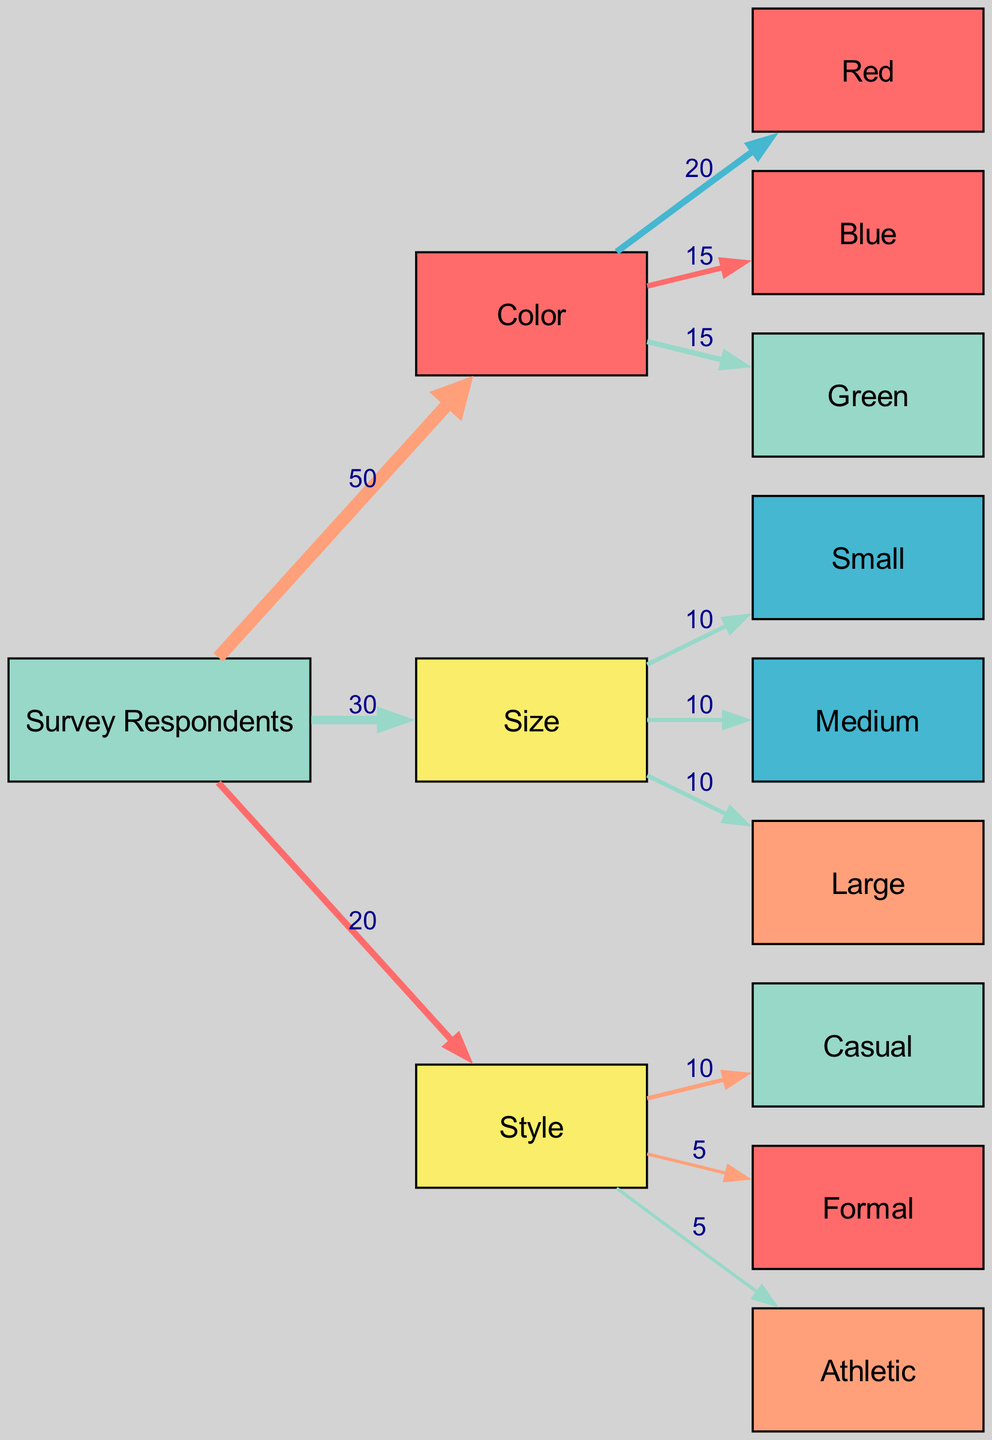What's the total number of survey respondents? The sum of all connections originating from the "Survey Respondents" node indicates the number of respondents. There is one link from "Survey Respondents" to each feature category (Color, Size, and Style) with respective values (50, 30, and 20). The connections themselves do not require further additions; the value of 50 signifies the total survey respondents.
Answer: 50 Which color has the highest preference among respondents? The flows from the "Color" node show the distribution among color choices. The values indicate preference ranking: Red (20), Blue (15), and Green (15). The highest value corresponds to 'Red', making it the most preferred color.
Answer: Red How many sizes are represented in the survey responses? Analyzing the "Size" node indicates that there are three connections leading to size options: Small, Medium, and Large. Each of these represents a distinct size category, so counting them gives the total number of size options.
Answer: 3 What percentage of respondents prefer Casual style? The "Style" node shows connections to Casual (10), Formal (5), and Athletic (5). Adding these values demonstrates that Casual's preference can be evaluated against the total number of respondents (50). Calculating (10/50) * 100 gives the percentage of those who prefer Casual style.
Answer: 20% What is the total preference value attributed to styles? The connections from the "Style" node indicate values for each style: Casual (10), Formal (5), and Athletic (5). Adding these values (10 + 5 + 5) provides the total preference value attributed to styles found in the survey responses.
Answer: 20 Which size category received equal preferences from respondents? In the flow from the "Size" node, there are three equal connections for Small (10), Medium (10), and Large (10). The sizes of Small and Medium have identical preference values, so both categories received equal preferences.
Answer: Small and Medium What is the lowest preference value for color options? Observing the "Color" connections reveals the values: Red (20), Blue (15), and Green (15). Among these, both Blue and Green share the lowest value of 15.
Answer: Blue and Green Which product feature category received the least attention from respondents? The flow from the "Survey Respondents" node to features shows 50 for Color, 30 for Size, and 20 for Style. The least amount of attention was given to Style, as indicated by the lowest numerical link from "Survey Respondents" to "Style".
Answer: Style How many edges are represented in total for color preferences? The "Color" node connects to three color options: Red, Blue, and Green, each represented by an edge. Therefore, counting these edges provides a measure of how many distinct preferences there are for colors in the survey.
Answer: 3 